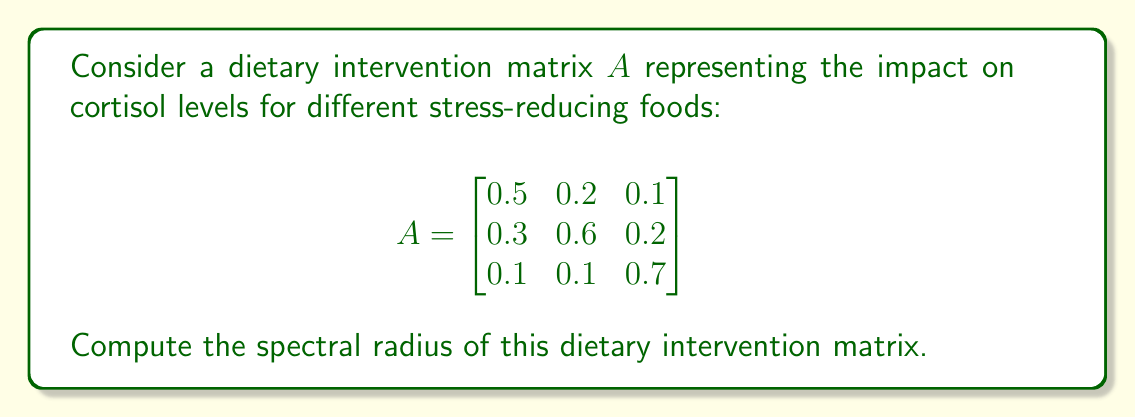Can you solve this math problem? To find the spectral radius of matrix $A$, we need to follow these steps:

1) First, calculate the characteristic polynomial of $A$:
   $det(A - \lambda I) = 0$
   
   $$\begin{vmatrix}
   0.5-\lambda & 0.2 & 0.1 \\
   0.3 & 0.6-\lambda & 0.2 \\
   0.1 & 0.1 & 0.7-\lambda
   \end{vmatrix} = 0$$

2) Expand the determinant:
   $(0.5-\lambda)[(0.6-\lambda)(0.7-\lambda)-0.02] - 0.2[0.3(0.7-\lambda)-0.02] + 0.1[0.3(0.1)-0.1(0.6-\lambda)] = 0$

3) Simplify:
   $-\lambda^3 + 1.8\lambda^2 - 0.95\lambda + 0.15 = 0$

4) Find the roots of this polynomial. These are the eigenvalues of $A$. 
   Using a numerical method or computer algebra system, we get:
   $\lambda_1 \approx 0.9053$
   $\lambda_2 \approx 0.4973 + 0.1476i$
   $\lambda_3 \approx 0.4973 - 0.1476i$

5) The spectral radius $\rho(A)$ is the maximum of the absolute values of these eigenvalues:

   $\rho(A) = \max(|\lambda_1|, |\lambda_2|, |\lambda_3|)$
   
   $|\lambda_1| \approx 0.9053$
   $|\lambda_2| = |\lambda_3| \approx \sqrt{0.4973^2 + 0.1476^2} \approx 0.5188$

6) Therefore, the spectral radius is approximately 0.9053.
Answer: $\rho(A) \approx 0.9053$ 